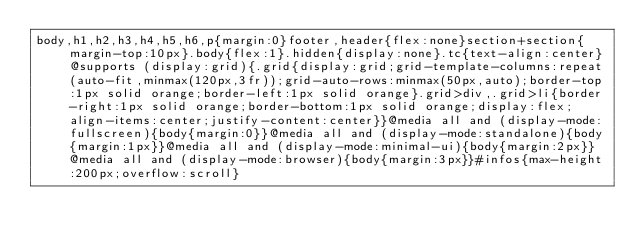<code> <loc_0><loc_0><loc_500><loc_500><_CSS_>body,h1,h2,h3,h4,h5,h6,p{margin:0}footer,header{flex:none}section+section{margin-top:10px}.body{flex:1}.hidden{display:none}.tc{text-align:center}@supports (display:grid){.grid{display:grid;grid-template-columns:repeat(auto-fit,minmax(120px,3fr));grid-auto-rows:minmax(50px,auto);border-top:1px solid orange;border-left:1px solid orange}.grid>div,.grid>li{border-right:1px solid orange;border-bottom:1px solid orange;display:flex;align-items:center;justify-content:center}}@media all and (display-mode:fullscreen){body{margin:0}}@media all and (display-mode:standalone){body{margin:1px}}@media all and (display-mode:minimal-ui){body{margin:2px}}@media all and (display-mode:browser){body{margin:3px}}#infos{max-height:200px;overflow:scroll}</code> 